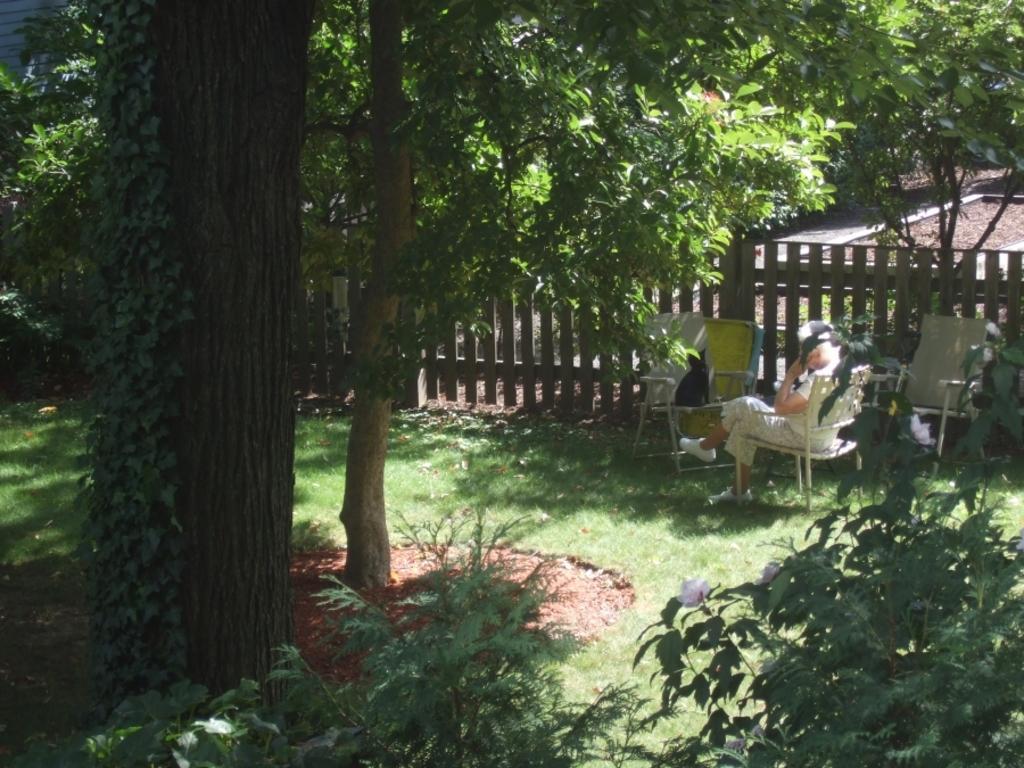Could you give a brief overview of what you see in this image? In this image, we can see some green color plants and trees, at the right side there is a person sitting on the chair, there is a fencing. 